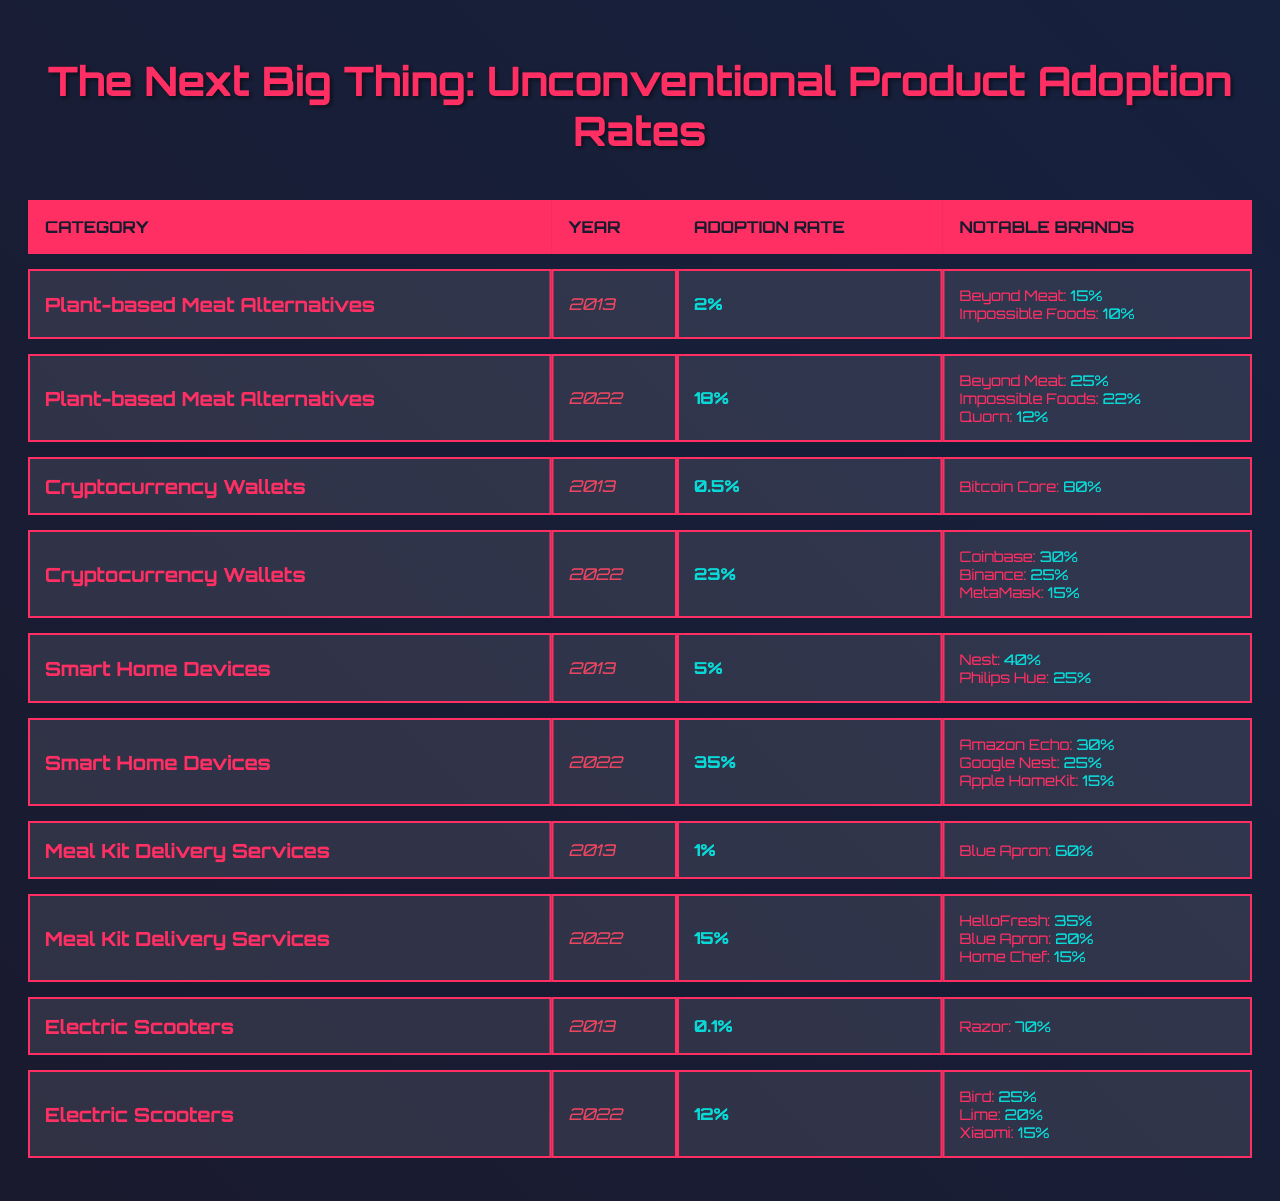What was the adoption rate of Plant-based Meat Alternatives in 2013? According to the table, the adoption rate for Plant-based Meat Alternatives in 2013 is stated directly as 2%
Answer: 2% What were the notable brands for Cryptocurrency Wallets in 2022? The table lists the notable brands for Cryptocurrency Wallets in 2022 as Coinbase, Binance, and MetaMask
Answer: Coinbase, Binance, MetaMask Did Smart Home Devices have a higher adoption rate than Meal Kit Delivery Services in 2022? In 2022, Smart Home Devices had an adoption rate of 35%, while Meal Kit Delivery Services had an adoption rate of 15%. Since 35% is greater than 15%, the answer is yes
Answer: Yes What is the difference between the adoption rates of Electric Scooters in 2013 and 2022? The adoption rate for Electric Scooters in 2013 is 0.1% and in 2022 it is 12%. The difference is calculated as 12% - 0.1% = 11.9%
Answer: 11.9% Which unconventional product category saw the greatest increase in adoption rate from 2013 to 2022? By comparing the adoption rates: Plant-based Meat Alternatives increased from 2% to 18% (16% increase), Cryptocurrency Wallets from 0.5% to 23% (22.5% increase), Smart Home Devices from 5% to 35% (30% increase), Meal Kit Delivery Services from 1% to 15% (14% increase), and Electric Scooters from 0.1% to 12% (11.9% increase). Cryptocurrency Wallets had the greatest increase of 22.5%
Answer: Cryptocurrency Wallets What percentage of the market share did Beyond Meat hold in 2022? The table indicates that Beyond Meat had a market share of 25% in 2022 under the Plant-based Meat Alternatives category
Answer: 25% 